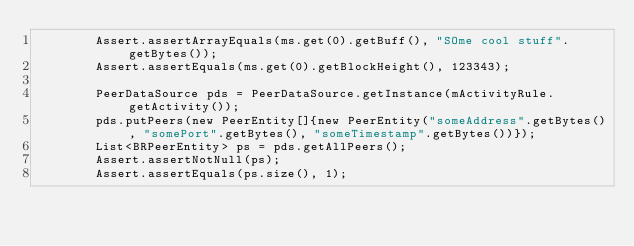Convert code to text. <code><loc_0><loc_0><loc_500><loc_500><_Java_>        Assert.assertArrayEquals(ms.get(0).getBuff(), "SOme cool stuff".getBytes());
        Assert.assertEquals(ms.get(0).getBlockHeight(), 123343);

        PeerDataSource pds = PeerDataSource.getInstance(mActivityRule.getActivity());
        pds.putPeers(new PeerEntity[]{new PeerEntity("someAddress".getBytes(), "somePort".getBytes(), "someTimestamp".getBytes())});
        List<BRPeerEntity> ps = pds.getAllPeers();
        Assert.assertNotNull(ps);
        Assert.assertEquals(ps.size(), 1);</code> 